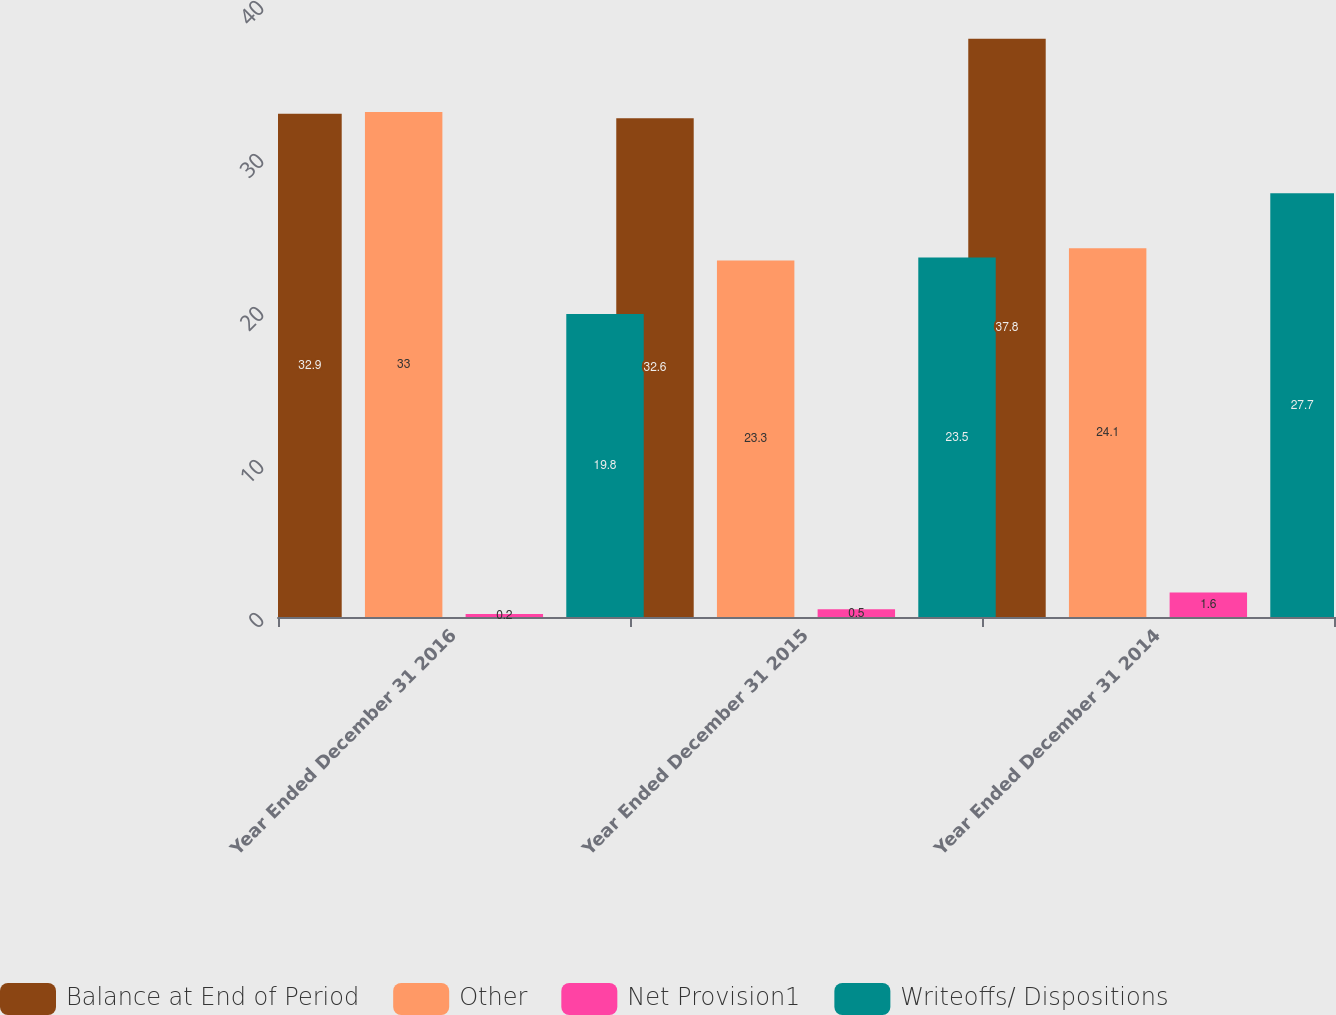<chart> <loc_0><loc_0><loc_500><loc_500><stacked_bar_chart><ecel><fcel>Year Ended December 31 2016<fcel>Year Ended December 31 2015<fcel>Year Ended December 31 2014<nl><fcel>Balance at End of Period<fcel>32.9<fcel>32.6<fcel>37.8<nl><fcel>Other<fcel>33<fcel>23.3<fcel>24.1<nl><fcel>Net Provision1<fcel>0.2<fcel>0.5<fcel>1.6<nl><fcel>Writeoffs/ Dispositions<fcel>19.8<fcel>23.5<fcel>27.7<nl></chart> 